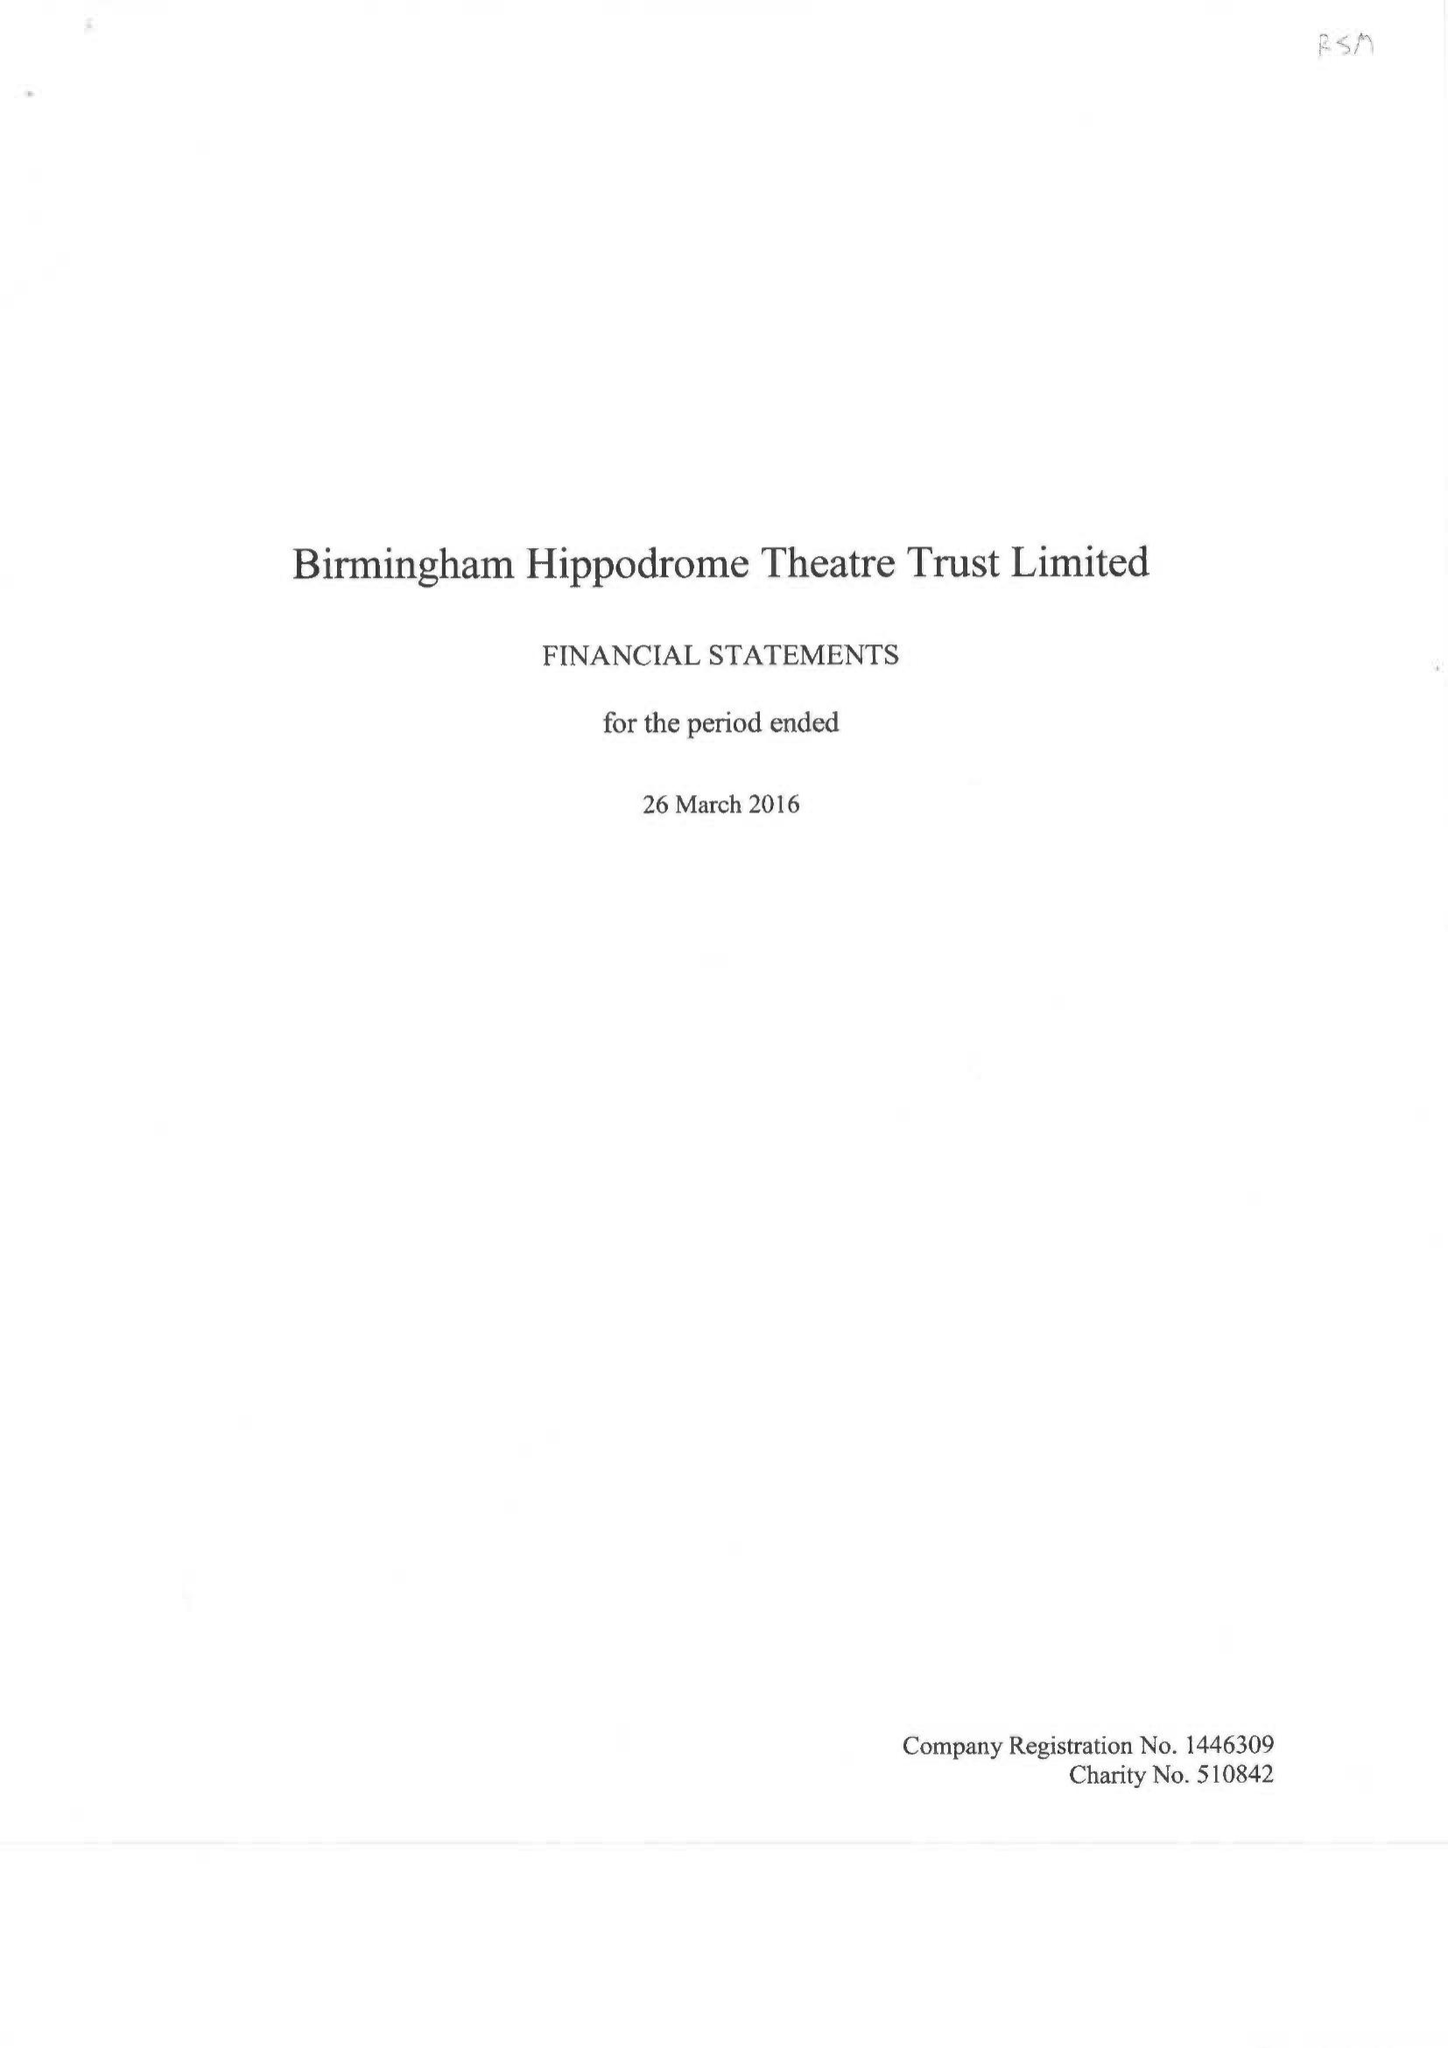What is the value for the charity_number?
Answer the question using a single word or phrase. 510842 